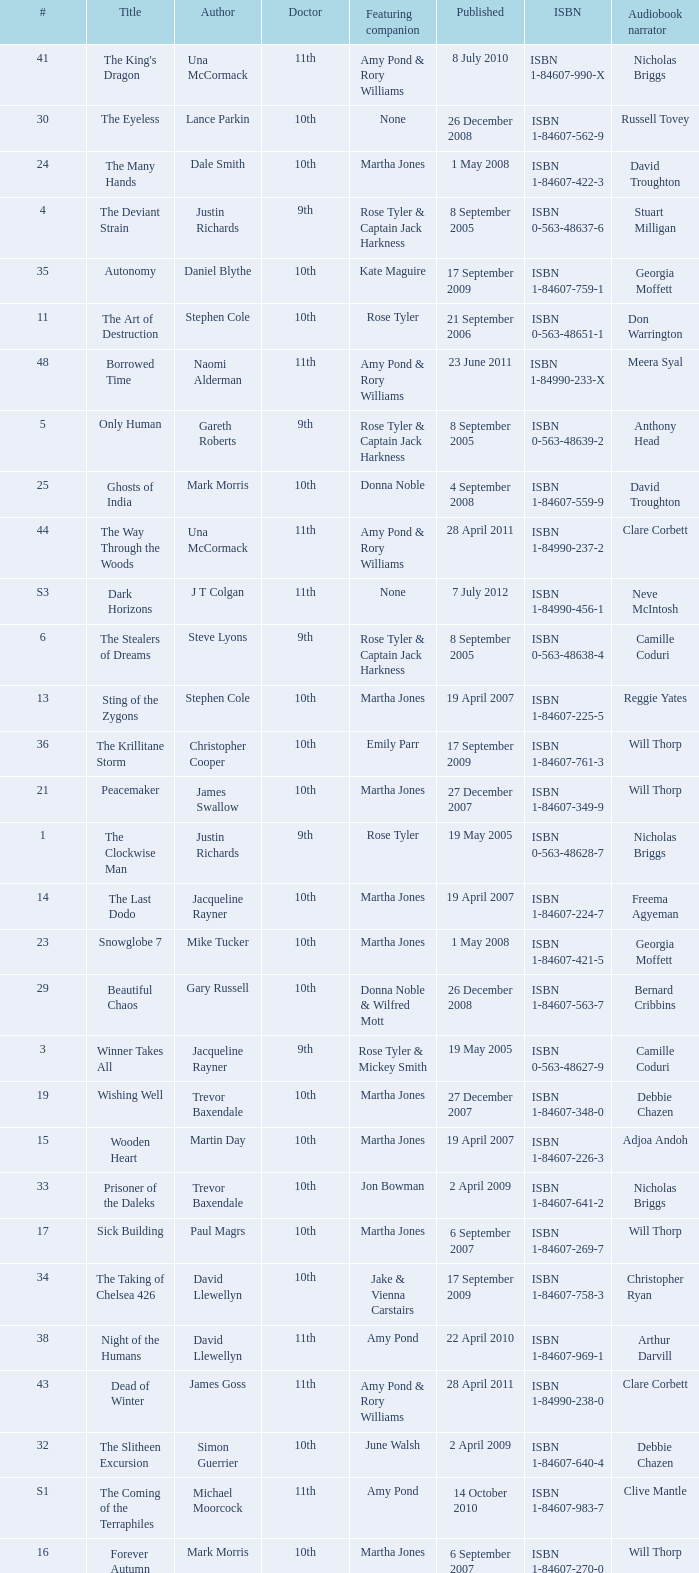What is the title of book number 8? The Feast of the Drowned. 